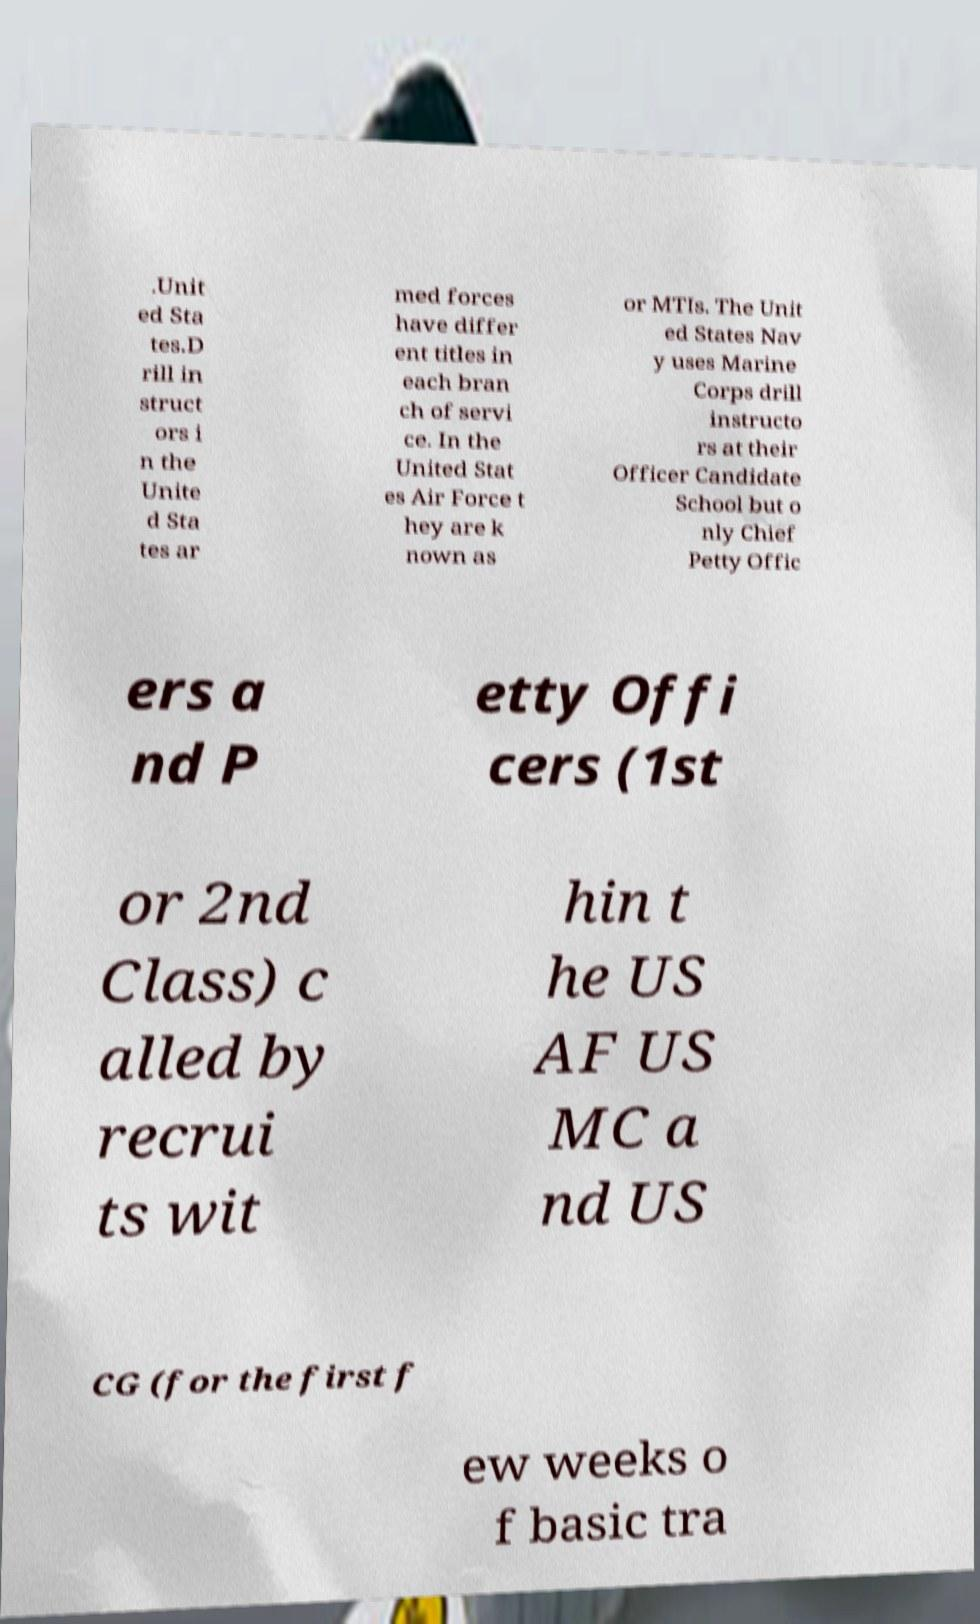Could you assist in decoding the text presented in this image and type it out clearly? .Unit ed Sta tes.D rill in struct ors i n the Unite d Sta tes ar med forces have differ ent titles in each bran ch of servi ce. In the United Stat es Air Force t hey are k nown as or MTIs. The Unit ed States Nav y uses Marine Corps drill instructo rs at their Officer Candidate School but o nly Chief Petty Offic ers a nd P etty Offi cers (1st or 2nd Class) c alled by recrui ts wit hin t he US AF US MC a nd US CG (for the first f ew weeks o f basic tra 